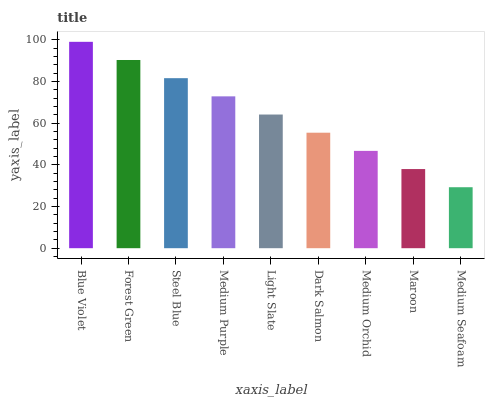Is Medium Seafoam the minimum?
Answer yes or no. Yes. Is Blue Violet the maximum?
Answer yes or no. Yes. Is Forest Green the minimum?
Answer yes or no. No. Is Forest Green the maximum?
Answer yes or no. No. Is Blue Violet greater than Forest Green?
Answer yes or no. Yes. Is Forest Green less than Blue Violet?
Answer yes or no. Yes. Is Forest Green greater than Blue Violet?
Answer yes or no. No. Is Blue Violet less than Forest Green?
Answer yes or no. No. Is Light Slate the high median?
Answer yes or no. Yes. Is Light Slate the low median?
Answer yes or no. Yes. Is Maroon the high median?
Answer yes or no. No. Is Medium Seafoam the low median?
Answer yes or no. No. 